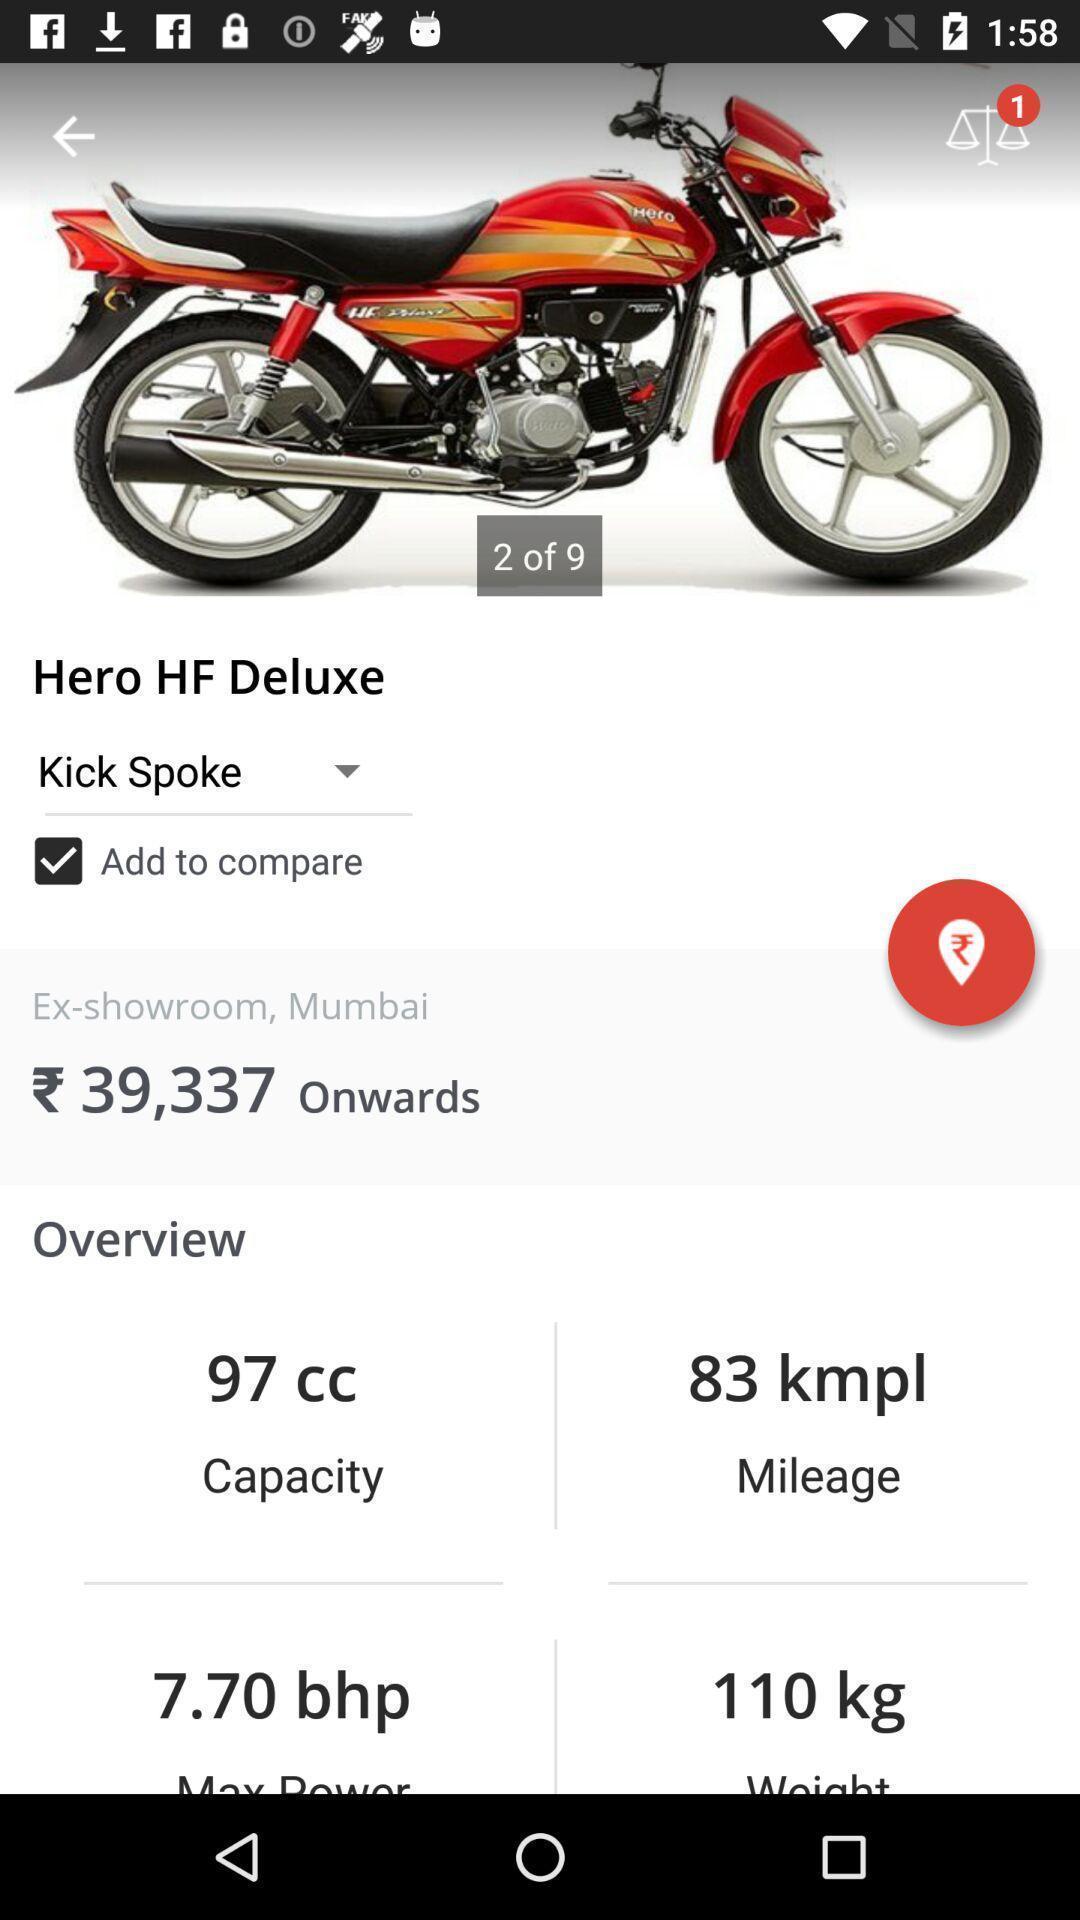Describe this image in words. Pop up displaying the price and details of a bike. 